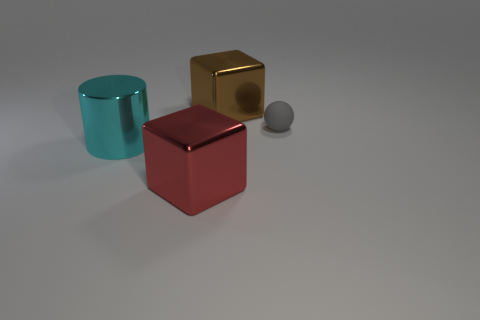Is there any other thing that has the same size as the gray sphere?
Your answer should be very brief. No. What shape is the object that is both to the left of the tiny ball and behind the big cyan thing?
Keep it short and to the point. Cube. The small object behind the shiny block in front of the large metallic thing behind the sphere is made of what material?
Give a very brief answer. Rubber. Are there more red blocks in front of the big cyan shiny object than gray spheres behind the small matte object?
Offer a terse response. Yes. How many balls are the same material as the gray object?
Keep it short and to the point. 0. Does the object that is on the right side of the big brown shiny thing have the same shape as the metal object left of the big red object?
Keep it short and to the point. No. What is the color of the big block that is to the left of the big brown metallic block?
Your answer should be compact. Red. Is there another metallic thing of the same shape as the red object?
Give a very brief answer. Yes. What is the cyan cylinder made of?
Provide a short and direct response. Metal. There is a object that is both in front of the big brown object and right of the large red object; how big is it?
Make the answer very short. Small. 